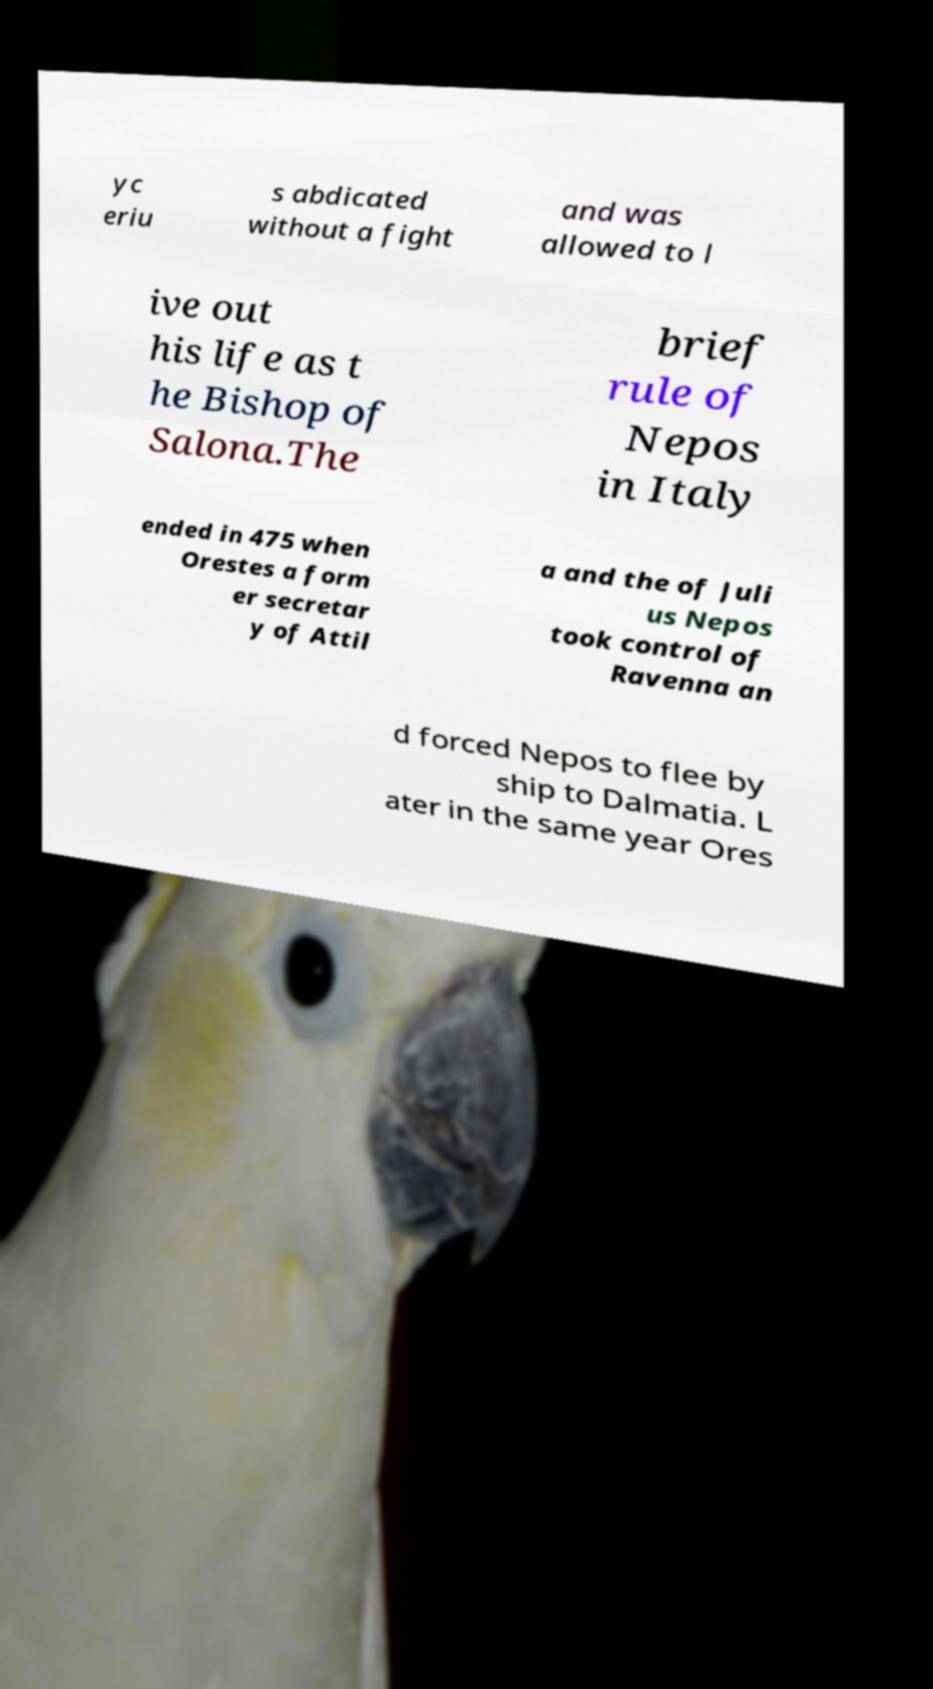Can you read and provide the text displayed in the image?This photo seems to have some interesting text. Can you extract and type it out for me? yc eriu s abdicated without a fight and was allowed to l ive out his life as t he Bishop of Salona.The brief rule of Nepos in Italy ended in 475 when Orestes a form er secretar y of Attil a and the of Juli us Nepos took control of Ravenna an d forced Nepos to flee by ship to Dalmatia. L ater in the same year Ores 